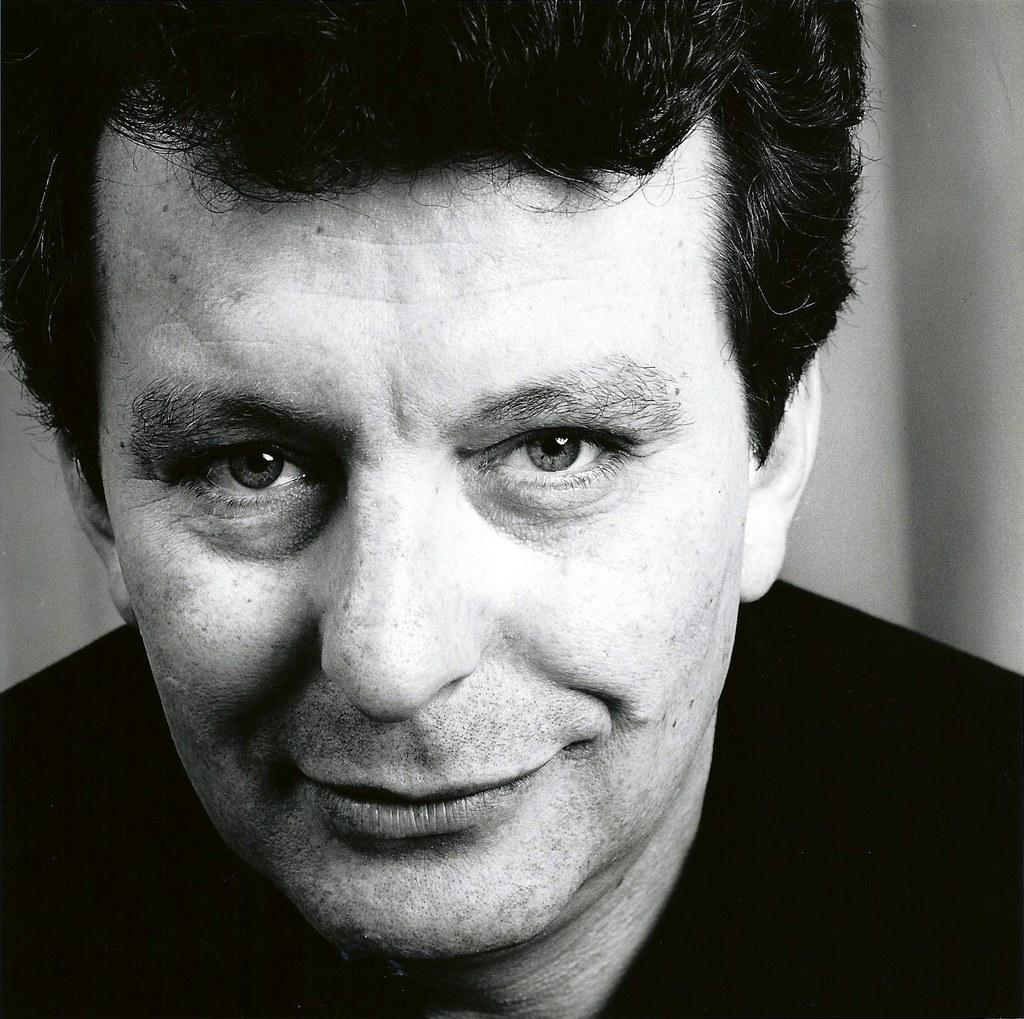What is the color scheme of the image? The image is black and white. Who is present in the image? There is a man in the image. What is the man doing in the image? The man is smiling and posing for the photo. What type of cable can be seen connecting the man to the moon in the image? There is no cable connecting the man to the moon in the image, nor is there any indication of the moon being present. 